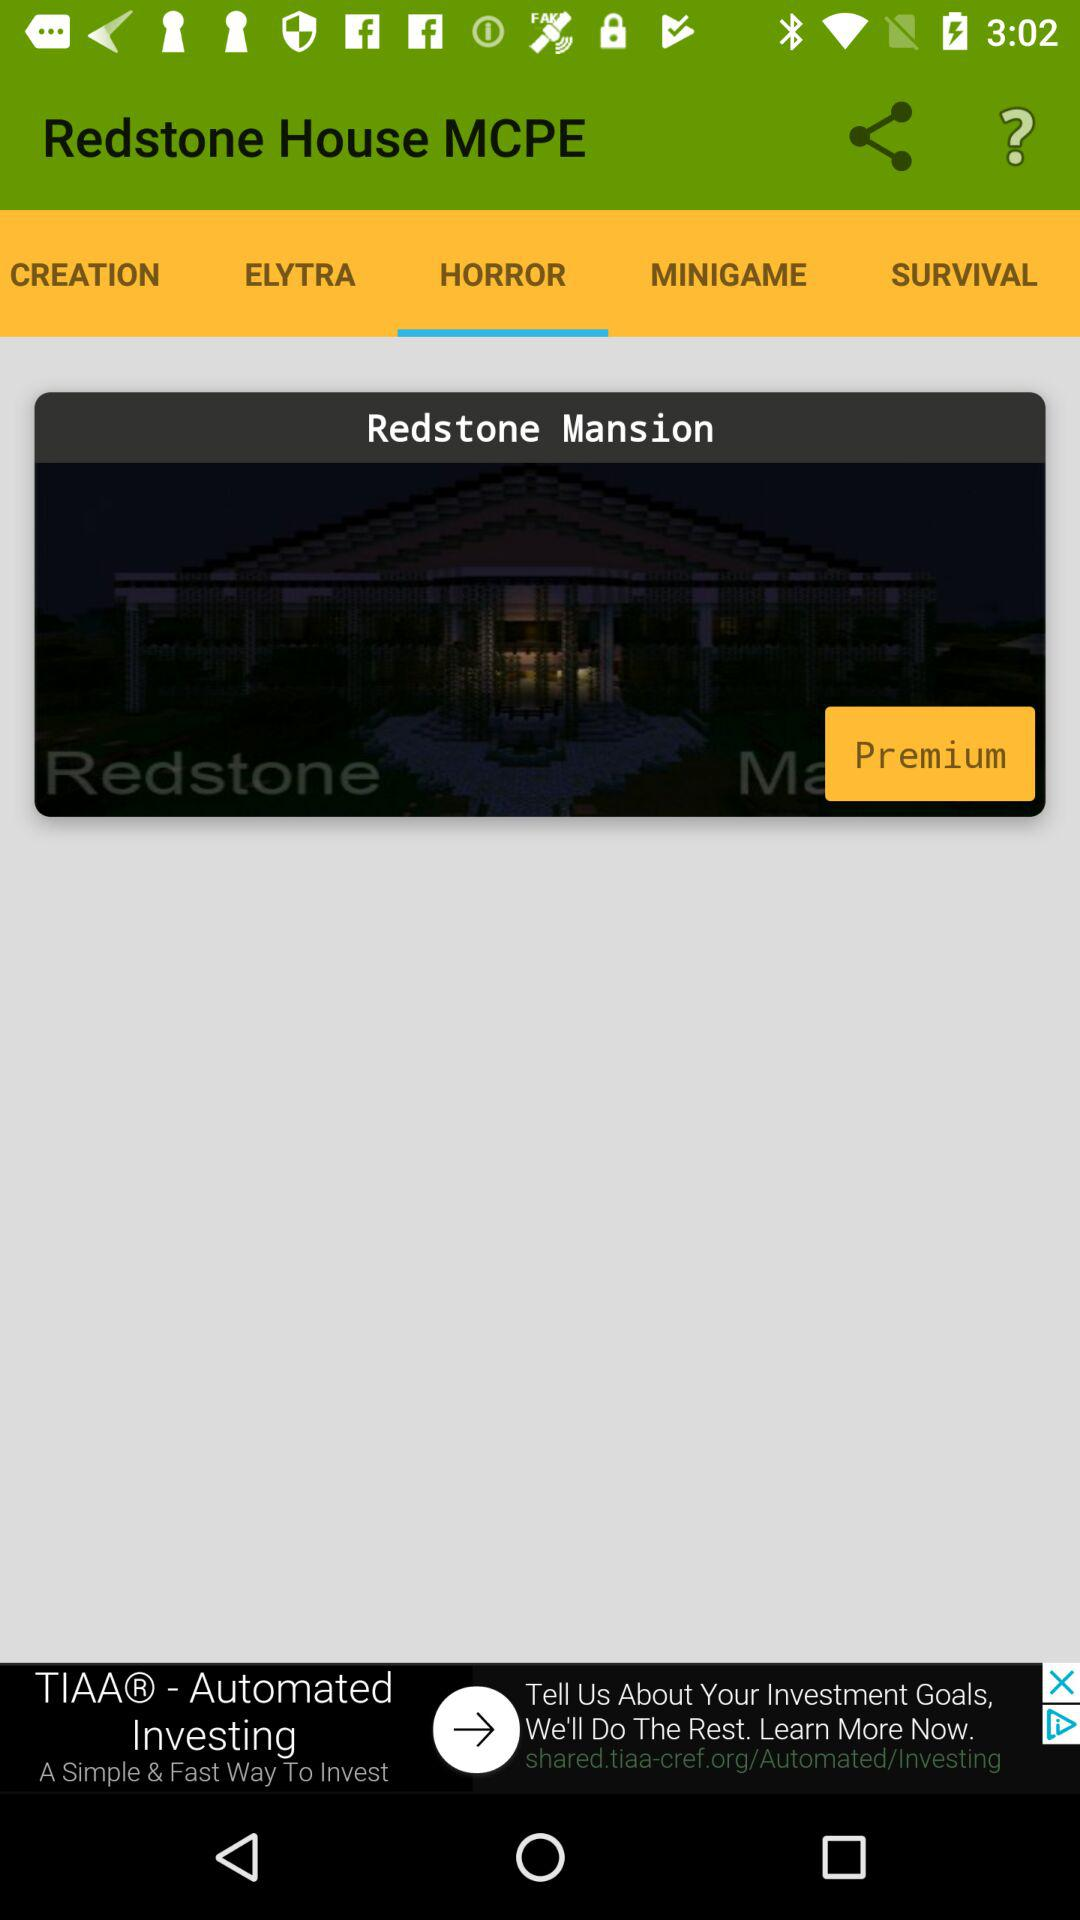Which tab is selected? The selected tab is "HORROR". 